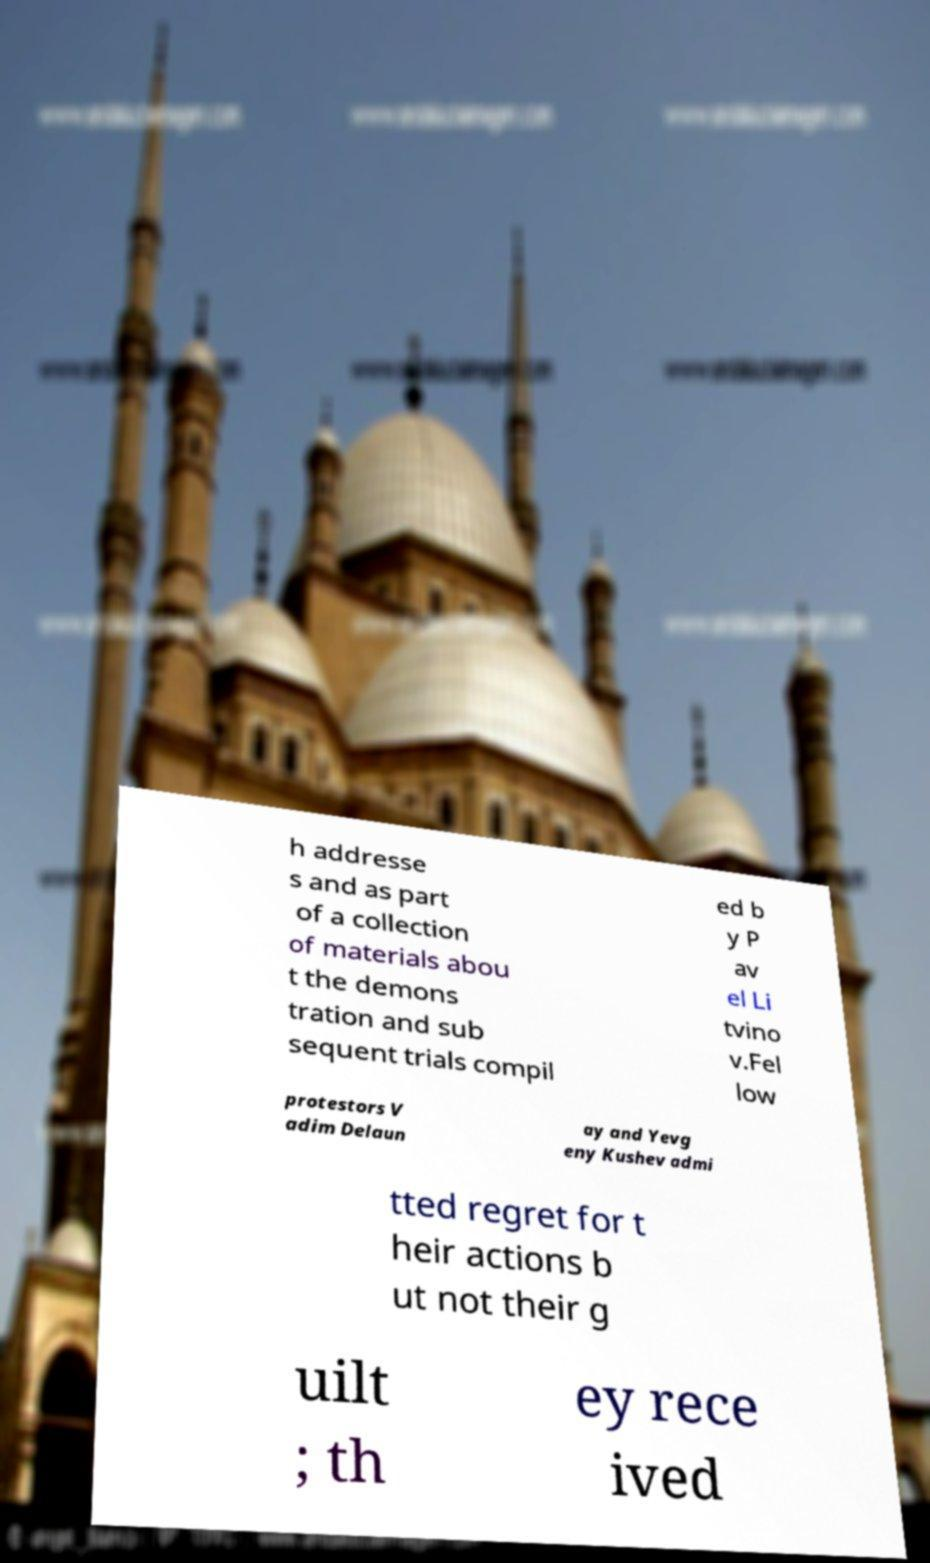Can you read and provide the text displayed in the image?This photo seems to have some interesting text. Can you extract and type it out for me? h addresse s and as part of a collection of materials abou t the demons tration and sub sequent trials compil ed b y P av el Li tvino v.Fel low protestors V adim Delaun ay and Yevg eny Kushev admi tted regret for t heir actions b ut not their g uilt ; th ey rece ived 